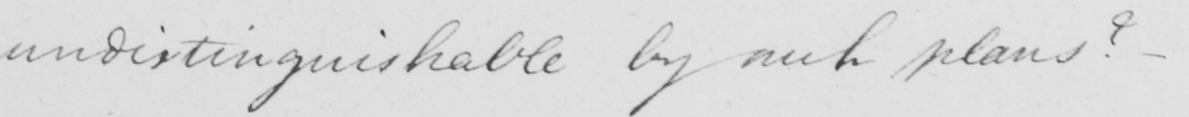Please transcribe the handwritten text in this image. indistinguishable by such plans ? - 